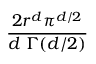<formula> <loc_0><loc_0><loc_500><loc_500>\frac { 2 r ^ { d } \pi ^ { d / 2 } } { d \, \Gamma ( d / 2 ) }</formula> 